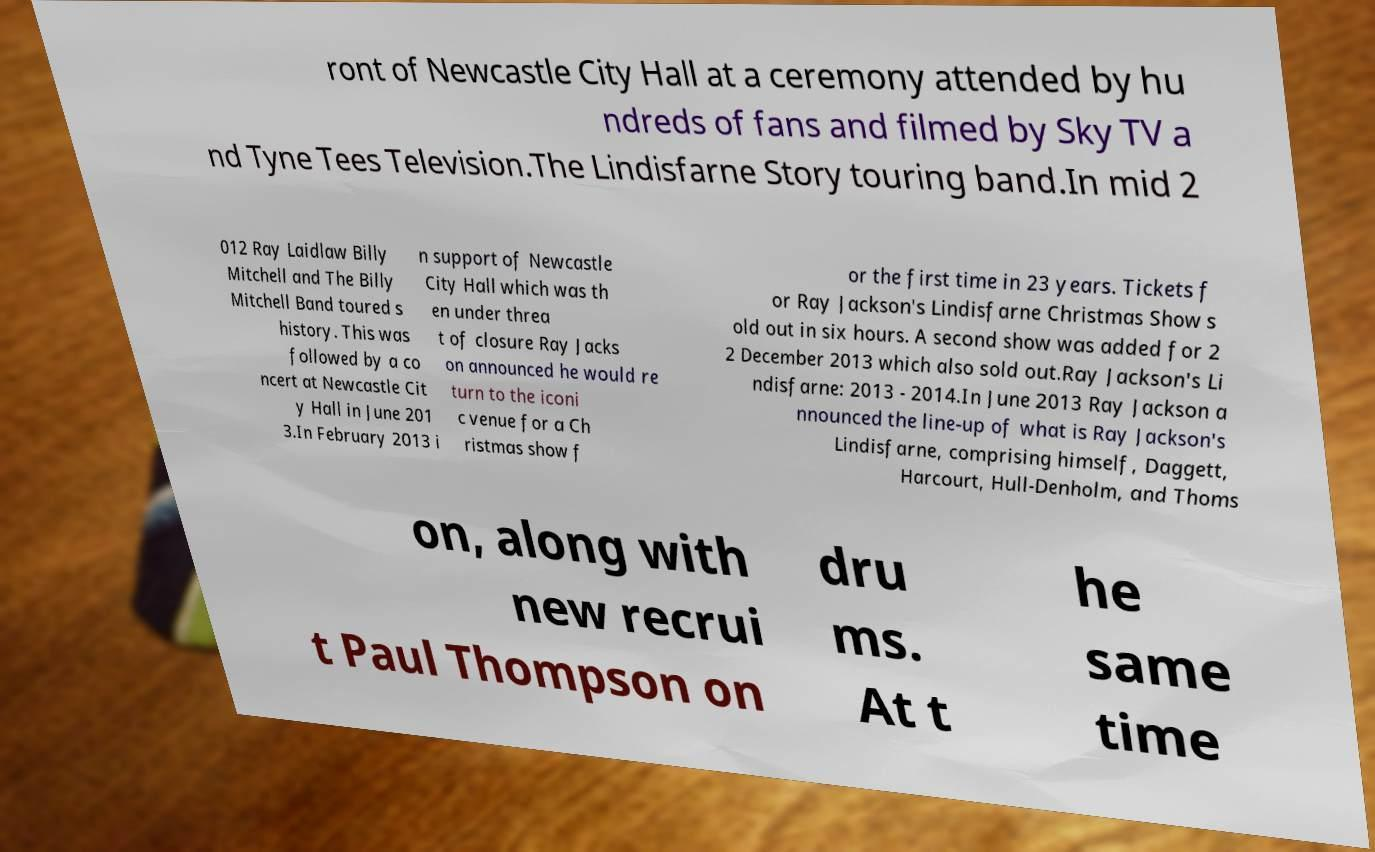What messages or text are displayed in this image? I need them in a readable, typed format. ront of Newcastle City Hall at a ceremony attended by hu ndreds of fans and filmed by Sky TV a nd Tyne Tees Television.The Lindisfarne Story touring band.In mid 2 012 Ray Laidlaw Billy Mitchell and The Billy Mitchell Band toured s history. This was followed by a co ncert at Newcastle Cit y Hall in June 201 3.In February 2013 i n support of Newcastle City Hall which was th en under threa t of closure Ray Jacks on announced he would re turn to the iconi c venue for a Ch ristmas show f or the first time in 23 years. Tickets f or Ray Jackson's Lindisfarne Christmas Show s old out in six hours. A second show was added for 2 2 December 2013 which also sold out.Ray Jackson's Li ndisfarne: 2013 - 2014.In June 2013 Ray Jackson a nnounced the line-up of what is Ray Jackson's Lindisfarne, comprising himself, Daggett, Harcourt, Hull-Denholm, and Thoms on, along with new recrui t Paul Thompson on dru ms. At t he same time 